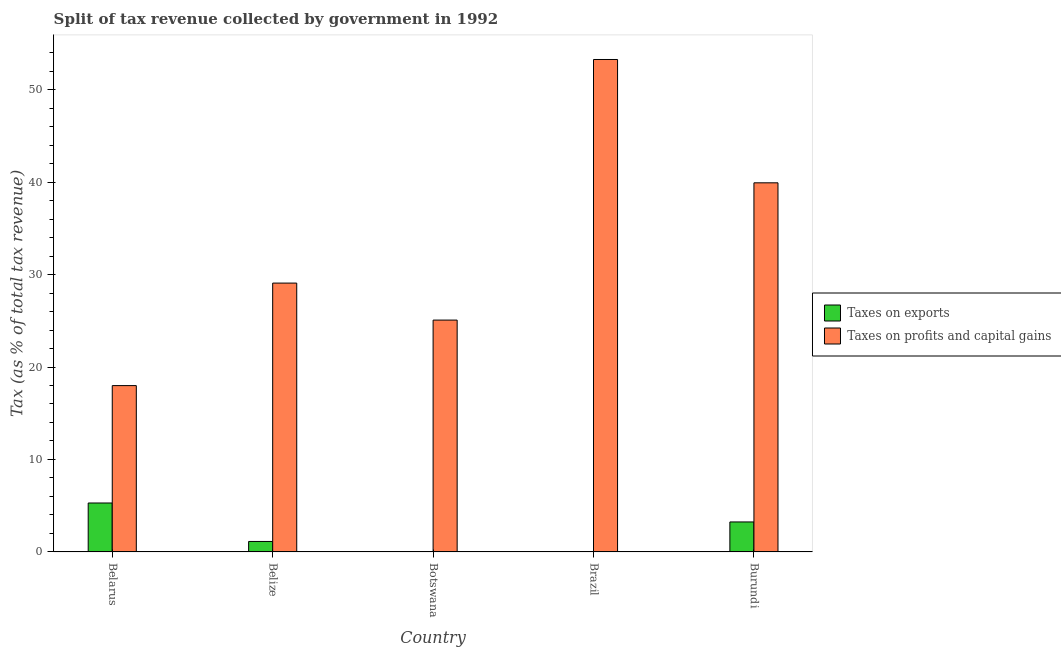How many different coloured bars are there?
Your response must be concise. 2. How many groups of bars are there?
Your answer should be compact. 5. How many bars are there on the 5th tick from the left?
Ensure brevity in your answer.  2. What is the label of the 1st group of bars from the left?
Your answer should be very brief. Belarus. In how many cases, is the number of bars for a given country not equal to the number of legend labels?
Provide a succinct answer. 0. What is the percentage of revenue obtained from taxes on exports in Brazil?
Provide a short and direct response. 0. Across all countries, what is the maximum percentage of revenue obtained from taxes on exports?
Offer a terse response. 5.29. Across all countries, what is the minimum percentage of revenue obtained from taxes on exports?
Offer a very short reply. 0. In which country was the percentage of revenue obtained from taxes on exports maximum?
Make the answer very short. Belarus. In which country was the percentage of revenue obtained from taxes on profits and capital gains minimum?
Your answer should be very brief. Belarus. What is the total percentage of revenue obtained from taxes on exports in the graph?
Offer a terse response. 9.69. What is the difference between the percentage of revenue obtained from taxes on exports in Belarus and that in Belize?
Your answer should be compact. 4.16. What is the difference between the percentage of revenue obtained from taxes on profits and capital gains in Belarus and the percentage of revenue obtained from taxes on exports in Belize?
Keep it short and to the point. 16.86. What is the average percentage of revenue obtained from taxes on exports per country?
Your response must be concise. 1.94. What is the difference between the percentage of revenue obtained from taxes on profits and capital gains and percentage of revenue obtained from taxes on exports in Belarus?
Your response must be concise. 12.7. What is the ratio of the percentage of revenue obtained from taxes on profits and capital gains in Belize to that in Burundi?
Offer a very short reply. 0.73. Is the percentage of revenue obtained from taxes on exports in Belarus less than that in Belize?
Keep it short and to the point. No. What is the difference between the highest and the second highest percentage of revenue obtained from taxes on profits and capital gains?
Your answer should be very brief. 13.34. What is the difference between the highest and the lowest percentage of revenue obtained from taxes on exports?
Give a very brief answer. 5.29. In how many countries, is the percentage of revenue obtained from taxes on profits and capital gains greater than the average percentage of revenue obtained from taxes on profits and capital gains taken over all countries?
Your answer should be compact. 2. What does the 2nd bar from the left in Burundi represents?
Your response must be concise. Taxes on profits and capital gains. What does the 2nd bar from the right in Belarus represents?
Offer a terse response. Taxes on exports. How many bars are there?
Keep it short and to the point. 10. Are all the bars in the graph horizontal?
Provide a succinct answer. No. What is the difference between two consecutive major ticks on the Y-axis?
Ensure brevity in your answer.  10. How are the legend labels stacked?
Your answer should be compact. Vertical. What is the title of the graph?
Offer a terse response. Split of tax revenue collected by government in 1992. What is the label or title of the Y-axis?
Give a very brief answer. Tax (as % of total tax revenue). What is the Tax (as % of total tax revenue) of Taxes on exports in Belarus?
Your response must be concise. 5.29. What is the Tax (as % of total tax revenue) in Taxes on profits and capital gains in Belarus?
Your answer should be very brief. 17.99. What is the Tax (as % of total tax revenue) in Taxes on exports in Belize?
Give a very brief answer. 1.13. What is the Tax (as % of total tax revenue) in Taxes on profits and capital gains in Belize?
Your answer should be very brief. 29.08. What is the Tax (as % of total tax revenue) in Taxes on exports in Botswana?
Keep it short and to the point. 0.02. What is the Tax (as % of total tax revenue) in Taxes on profits and capital gains in Botswana?
Make the answer very short. 25.08. What is the Tax (as % of total tax revenue) in Taxes on exports in Brazil?
Ensure brevity in your answer.  0. What is the Tax (as % of total tax revenue) of Taxes on profits and capital gains in Brazil?
Ensure brevity in your answer.  53.27. What is the Tax (as % of total tax revenue) of Taxes on exports in Burundi?
Provide a short and direct response. 3.24. What is the Tax (as % of total tax revenue) in Taxes on profits and capital gains in Burundi?
Your answer should be very brief. 39.93. Across all countries, what is the maximum Tax (as % of total tax revenue) in Taxes on exports?
Keep it short and to the point. 5.29. Across all countries, what is the maximum Tax (as % of total tax revenue) in Taxes on profits and capital gains?
Your answer should be compact. 53.27. Across all countries, what is the minimum Tax (as % of total tax revenue) in Taxes on exports?
Provide a short and direct response. 0. Across all countries, what is the minimum Tax (as % of total tax revenue) of Taxes on profits and capital gains?
Offer a terse response. 17.99. What is the total Tax (as % of total tax revenue) in Taxes on exports in the graph?
Your answer should be compact. 9.69. What is the total Tax (as % of total tax revenue) of Taxes on profits and capital gains in the graph?
Make the answer very short. 165.34. What is the difference between the Tax (as % of total tax revenue) in Taxes on exports in Belarus and that in Belize?
Your answer should be compact. 4.16. What is the difference between the Tax (as % of total tax revenue) of Taxes on profits and capital gains in Belarus and that in Belize?
Your answer should be compact. -11.09. What is the difference between the Tax (as % of total tax revenue) of Taxes on exports in Belarus and that in Botswana?
Your response must be concise. 5.27. What is the difference between the Tax (as % of total tax revenue) in Taxes on profits and capital gains in Belarus and that in Botswana?
Offer a very short reply. -7.09. What is the difference between the Tax (as % of total tax revenue) in Taxes on exports in Belarus and that in Brazil?
Provide a short and direct response. 5.29. What is the difference between the Tax (as % of total tax revenue) in Taxes on profits and capital gains in Belarus and that in Brazil?
Your answer should be compact. -35.28. What is the difference between the Tax (as % of total tax revenue) of Taxes on exports in Belarus and that in Burundi?
Your response must be concise. 2.05. What is the difference between the Tax (as % of total tax revenue) in Taxes on profits and capital gains in Belarus and that in Burundi?
Offer a very short reply. -21.94. What is the difference between the Tax (as % of total tax revenue) in Taxes on exports in Belize and that in Botswana?
Keep it short and to the point. 1.11. What is the difference between the Tax (as % of total tax revenue) in Taxes on profits and capital gains in Belize and that in Botswana?
Offer a very short reply. 4. What is the difference between the Tax (as % of total tax revenue) of Taxes on exports in Belize and that in Brazil?
Your answer should be compact. 1.13. What is the difference between the Tax (as % of total tax revenue) in Taxes on profits and capital gains in Belize and that in Brazil?
Provide a short and direct response. -24.19. What is the difference between the Tax (as % of total tax revenue) of Taxes on exports in Belize and that in Burundi?
Your answer should be very brief. -2.11. What is the difference between the Tax (as % of total tax revenue) in Taxes on profits and capital gains in Belize and that in Burundi?
Ensure brevity in your answer.  -10.85. What is the difference between the Tax (as % of total tax revenue) of Taxes on exports in Botswana and that in Brazil?
Provide a succinct answer. 0.02. What is the difference between the Tax (as % of total tax revenue) of Taxes on profits and capital gains in Botswana and that in Brazil?
Offer a terse response. -28.19. What is the difference between the Tax (as % of total tax revenue) of Taxes on exports in Botswana and that in Burundi?
Offer a very short reply. -3.22. What is the difference between the Tax (as % of total tax revenue) of Taxes on profits and capital gains in Botswana and that in Burundi?
Ensure brevity in your answer.  -14.85. What is the difference between the Tax (as % of total tax revenue) in Taxes on exports in Brazil and that in Burundi?
Make the answer very short. -3.24. What is the difference between the Tax (as % of total tax revenue) in Taxes on profits and capital gains in Brazil and that in Burundi?
Ensure brevity in your answer.  13.34. What is the difference between the Tax (as % of total tax revenue) in Taxes on exports in Belarus and the Tax (as % of total tax revenue) in Taxes on profits and capital gains in Belize?
Ensure brevity in your answer.  -23.79. What is the difference between the Tax (as % of total tax revenue) of Taxes on exports in Belarus and the Tax (as % of total tax revenue) of Taxes on profits and capital gains in Botswana?
Provide a short and direct response. -19.79. What is the difference between the Tax (as % of total tax revenue) in Taxes on exports in Belarus and the Tax (as % of total tax revenue) in Taxes on profits and capital gains in Brazil?
Make the answer very short. -47.97. What is the difference between the Tax (as % of total tax revenue) in Taxes on exports in Belarus and the Tax (as % of total tax revenue) in Taxes on profits and capital gains in Burundi?
Provide a short and direct response. -34.64. What is the difference between the Tax (as % of total tax revenue) in Taxes on exports in Belize and the Tax (as % of total tax revenue) in Taxes on profits and capital gains in Botswana?
Provide a short and direct response. -23.95. What is the difference between the Tax (as % of total tax revenue) of Taxes on exports in Belize and the Tax (as % of total tax revenue) of Taxes on profits and capital gains in Brazil?
Your answer should be compact. -52.14. What is the difference between the Tax (as % of total tax revenue) of Taxes on exports in Belize and the Tax (as % of total tax revenue) of Taxes on profits and capital gains in Burundi?
Ensure brevity in your answer.  -38.8. What is the difference between the Tax (as % of total tax revenue) of Taxes on exports in Botswana and the Tax (as % of total tax revenue) of Taxes on profits and capital gains in Brazil?
Offer a very short reply. -53.25. What is the difference between the Tax (as % of total tax revenue) of Taxes on exports in Botswana and the Tax (as % of total tax revenue) of Taxes on profits and capital gains in Burundi?
Give a very brief answer. -39.91. What is the difference between the Tax (as % of total tax revenue) of Taxes on exports in Brazil and the Tax (as % of total tax revenue) of Taxes on profits and capital gains in Burundi?
Your answer should be compact. -39.92. What is the average Tax (as % of total tax revenue) of Taxes on exports per country?
Your response must be concise. 1.94. What is the average Tax (as % of total tax revenue) of Taxes on profits and capital gains per country?
Your answer should be compact. 33.07. What is the difference between the Tax (as % of total tax revenue) in Taxes on exports and Tax (as % of total tax revenue) in Taxes on profits and capital gains in Belarus?
Offer a terse response. -12.7. What is the difference between the Tax (as % of total tax revenue) in Taxes on exports and Tax (as % of total tax revenue) in Taxes on profits and capital gains in Belize?
Provide a succinct answer. -27.95. What is the difference between the Tax (as % of total tax revenue) in Taxes on exports and Tax (as % of total tax revenue) in Taxes on profits and capital gains in Botswana?
Provide a succinct answer. -25.06. What is the difference between the Tax (as % of total tax revenue) in Taxes on exports and Tax (as % of total tax revenue) in Taxes on profits and capital gains in Brazil?
Keep it short and to the point. -53.26. What is the difference between the Tax (as % of total tax revenue) in Taxes on exports and Tax (as % of total tax revenue) in Taxes on profits and capital gains in Burundi?
Provide a succinct answer. -36.68. What is the ratio of the Tax (as % of total tax revenue) in Taxes on exports in Belarus to that in Belize?
Offer a terse response. 4.68. What is the ratio of the Tax (as % of total tax revenue) in Taxes on profits and capital gains in Belarus to that in Belize?
Your response must be concise. 0.62. What is the ratio of the Tax (as % of total tax revenue) in Taxes on exports in Belarus to that in Botswana?
Offer a very short reply. 257.77. What is the ratio of the Tax (as % of total tax revenue) of Taxes on profits and capital gains in Belarus to that in Botswana?
Make the answer very short. 0.72. What is the ratio of the Tax (as % of total tax revenue) in Taxes on exports in Belarus to that in Brazil?
Ensure brevity in your answer.  2750.86. What is the ratio of the Tax (as % of total tax revenue) in Taxes on profits and capital gains in Belarus to that in Brazil?
Ensure brevity in your answer.  0.34. What is the ratio of the Tax (as % of total tax revenue) of Taxes on exports in Belarus to that in Burundi?
Ensure brevity in your answer.  1.63. What is the ratio of the Tax (as % of total tax revenue) in Taxes on profits and capital gains in Belarus to that in Burundi?
Offer a very short reply. 0.45. What is the ratio of the Tax (as % of total tax revenue) of Taxes on exports in Belize to that in Botswana?
Provide a succinct answer. 55.08. What is the ratio of the Tax (as % of total tax revenue) in Taxes on profits and capital gains in Belize to that in Botswana?
Give a very brief answer. 1.16. What is the ratio of the Tax (as % of total tax revenue) in Taxes on exports in Belize to that in Brazil?
Ensure brevity in your answer.  587.78. What is the ratio of the Tax (as % of total tax revenue) of Taxes on profits and capital gains in Belize to that in Brazil?
Your answer should be very brief. 0.55. What is the ratio of the Tax (as % of total tax revenue) in Taxes on exports in Belize to that in Burundi?
Provide a short and direct response. 0.35. What is the ratio of the Tax (as % of total tax revenue) in Taxes on profits and capital gains in Belize to that in Burundi?
Make the answer very short. 0.73. What is the ratio of the Tax (as % of total tax revenue) of Taxes on exports in Botswana to that in Brazil?
Ensure brevity in your answer.  10.67. What is the ratio of the Tax (as % of total tax revenue) in Taxes on profits and capital gains in Botswana to that in Brazil?
Ensure brevity in your answer.  0.47. What is the ratio of the Tax (as % of total tax revenue) of Taxes on exports in Botswana to that in Burundi?
Make the answer very short. 0.01. What is the ratio of the Tax (as % of total tax revenue) in Taxes on profits and capital gains in Botswana to that in Burundi?
Make the answer very short. 0.63. What is the ratio of the Tax (as % of total tax revenue) of Taxes on exports in Brazil to that in Burundi?
Provide a succinct answer. 0. What is the ratio of the Tax (as % of total tax revenue) of Taxes on profits and capital gains in Brazil to that in Burundi?
Your answer should be compact. 1.33. What is the difference between the highest and the second highest Tax (as % of total tax revenue) in Taxes on exports?
Your response must be concise. 2.05. What is the difference between the highest and the second highest Tax (as % of total tax revenue) in Taxes on profits and capital gains?
Provide a succinct answer. 13.34. What is the difference between the highest and the lowest Tax (as % of total tax revenue) in Taxes on exports?
Keep it short and to the point. 5.29. What is the difference between the highest and the lowest Tax (as % of total tax revenue) of Taxes on profits and capital gains?
Provide a short and direct response. 35.28. 